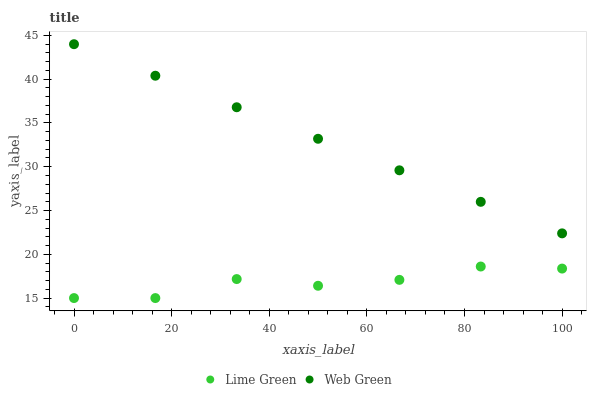Does Lime Green have the minimum area under the curve?
Answer yes or no. Yes. Does Web Green have the maximum area under the curve?
Answer yes or no. Yes. Does Web Green have the minimum area under the curve?
Answer yes or no. No. Is Web Green the smoothest?
Answer yes or no. Yes. Is Lime Green the roughest?
Answer yes or no. Yes. Is Web Green the roughest?
Answer yes or no. No. Does Lime Green have the lowest value?
Answer yes or no. Yes. Does Web Green have the lowest value?
Answer yes or no. No. Does Web Green have the highest value?
Answer yes or no. Yes. Is Lime Green less than Web Green?
Answer yes or no. Yes. Is Web Green greater than Lime Green?
Answer yes or no. Yes. Does Lime Green intersect Web Green?
Answer yes or no. No. 